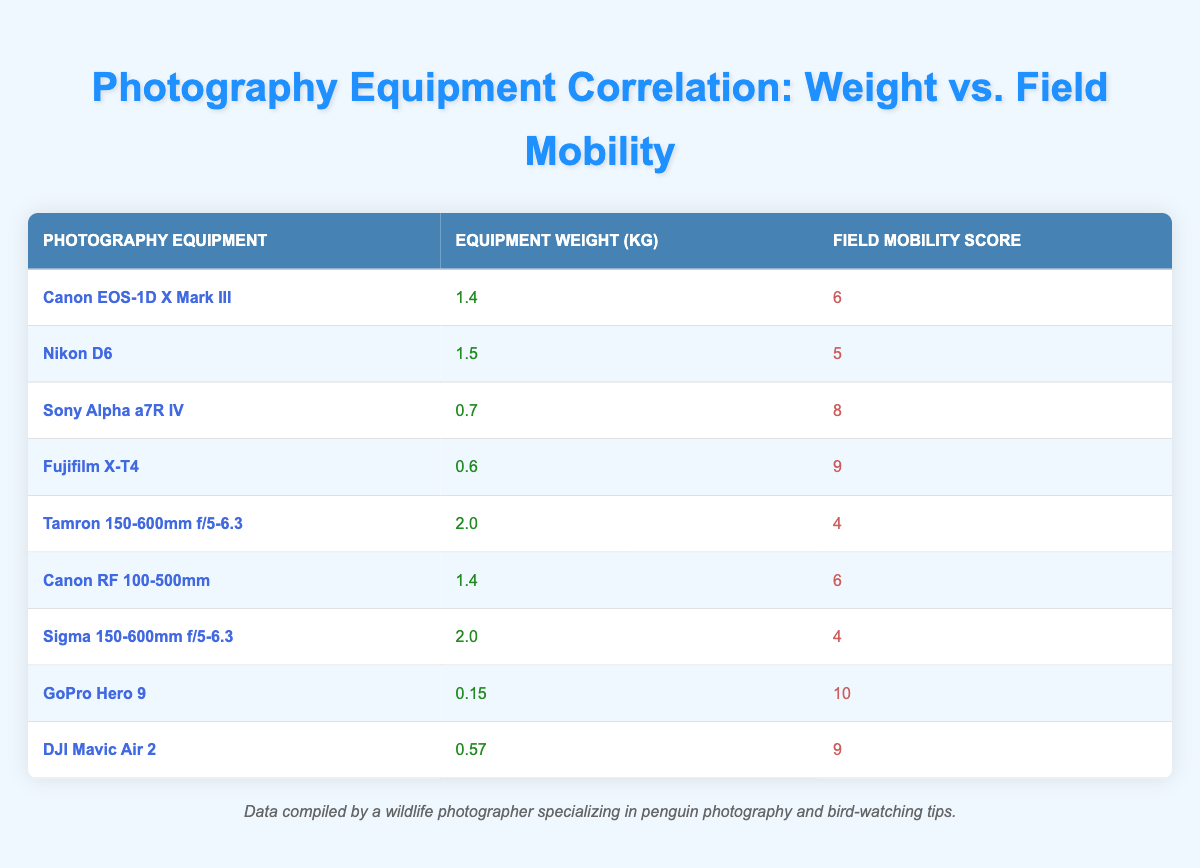What is the weight of the Fujifilm X-T4? The weight of the Fujifilm X-T4 is listed in the table under the "Equipment Weight (kg)" column. It shows that the weight is 0.6 kg.
Answer: 0.6 kg Which photography equipment has the highest field mobility score? By looking at the "Field Mobility Score" column, I can see that the GoPro Hero 9 has the highest score, which is 10.
Answer: GoPro Hero 9 What is the average equipment weight of all listed photography equipment? To calculate the average, I add up the weights of all equipment: (1.4 + 1.5 + 0.7 + 0.6 + 2.0 + 1.4 + 2.0 + 0.15 + 0.57) = 10.37 kg. There are 9 items, so the average weight is 10.37/9 ≈ 1.15 kg.
Answer: 1.15 kg Is there any equipment weighing less than 0.5 kg? By scanning the table, the lightest item is the GoPro Hero 9 at 0.15 kg, which is indeed less than 0.5 kg.
Answer: Yes What is the total field mobility score of equipment that weighs more than 1.5 kg? I need to identify the equipment weighing more than 1.5 kg, which are the Tamron 150-600mm f/5-6.3 and the Sigma 150-600mm f/5-6.3, both with a mobility score of 4. So the total score is 4 + 4 = 8.
Answer: 8 What is the difference in field mobility score between the heaviest and lightest equipment? The heaviest equipment is the Tamron 150-600mm f/5-6.3 and Sigma 150-600mm f/5-6.3 with scores of 4 each, and the lightest is the GoPro Hero 9 with a score of 10. The difference is 10 - 4 = 6.
Answer: 6 Which two pieces of equipment have the same weight? Looking through the "Equipment Weight (kg)" column, Canon EOS-1D X Mark III and Canon RF 100-500mm both weigh 1.4 kg, thus they are the two pieces of equipment with the same weight.
Answer: Canon EOS-1D X Mark III and Canon RF 100-500mm How does the field mobility score change as the equipment weight increases? Analyzing the table, as the weight of equipment increases (from 0.15 kg to 2.0 kg), the field mobility tends to decrease, indicating a negative correlation; for instance, lighter equipment has higher mobility scores.
Answer: It generally decreases 